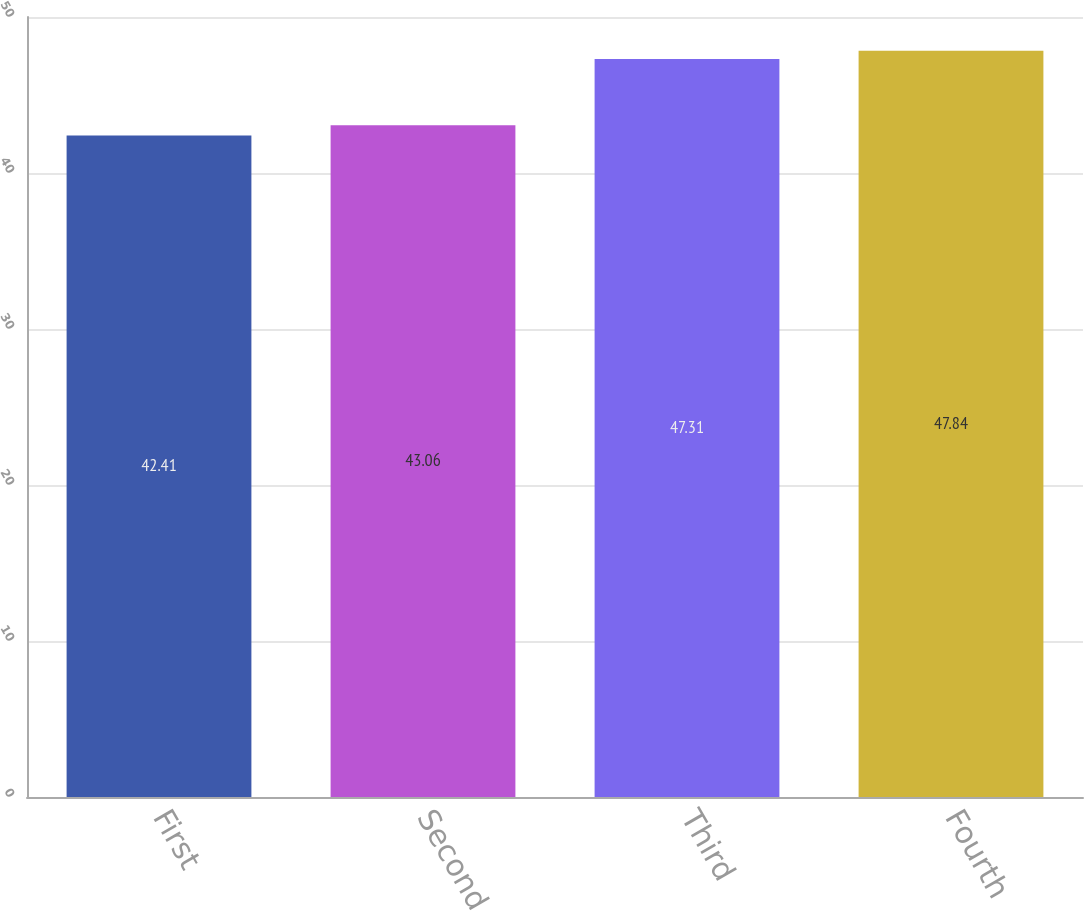Convert chart. <chart><loc_0><loc_0><loc_500><loc_500><bar_chart><fcel>First<fcel>Second<fcel>Third<fcel>Fourth<nl><fcel>42.41<fcel>43.06<fcel>47.31<fcel>47.84<nl></chart> 